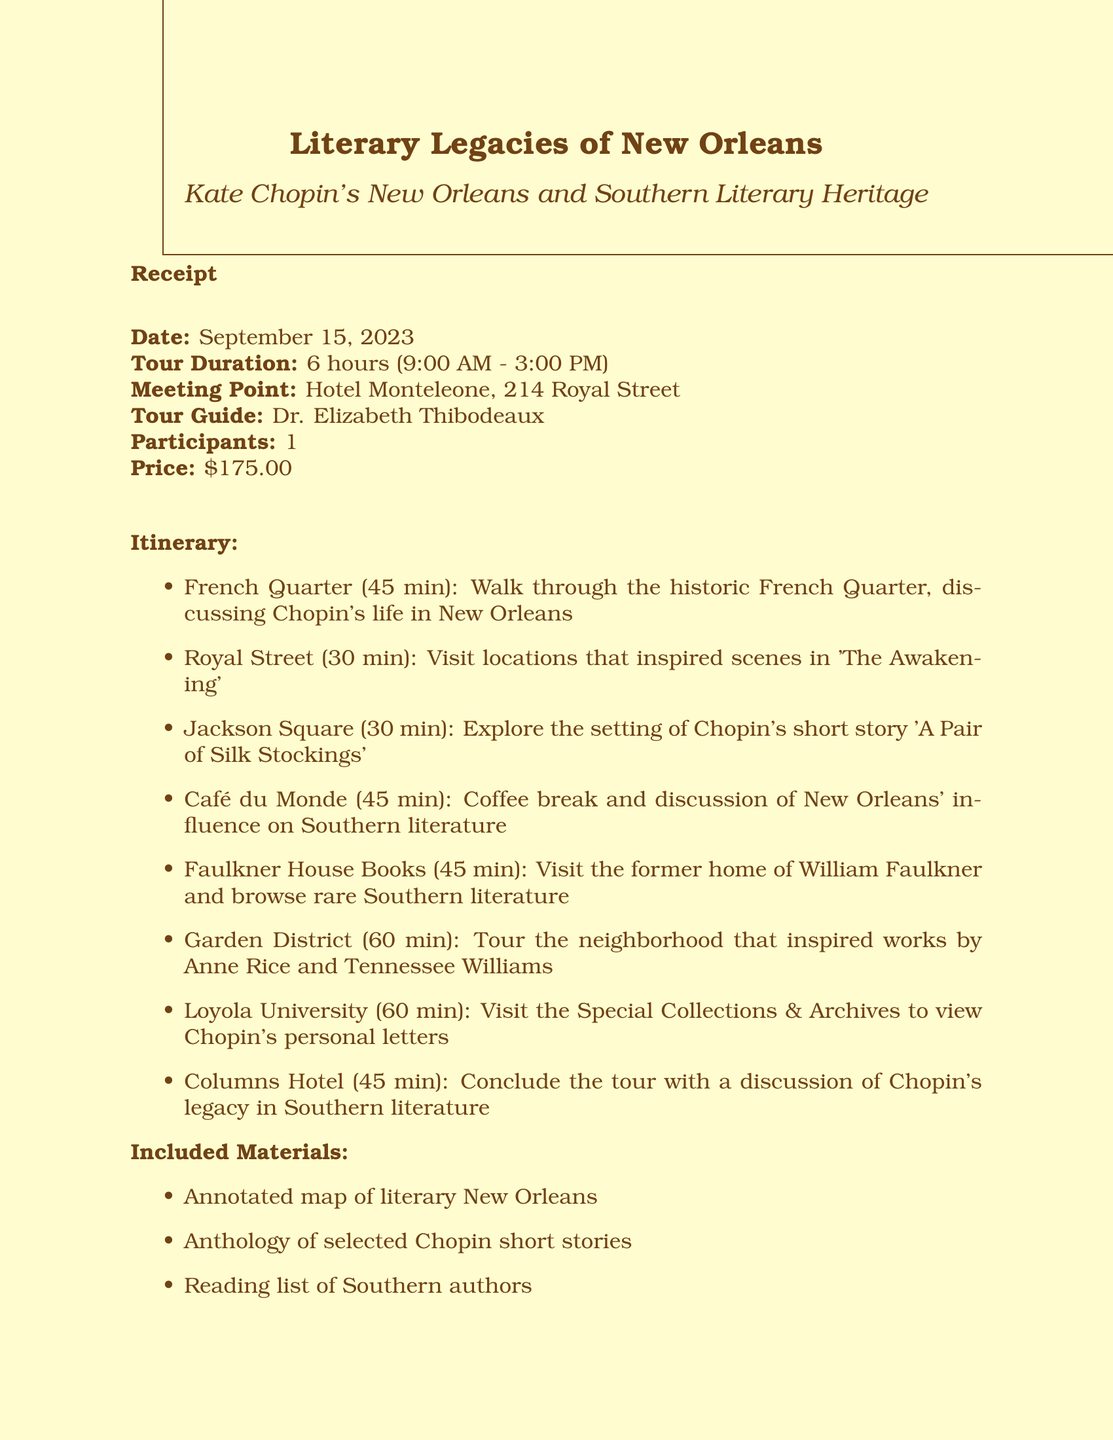What is the name of the tour company? The name of the tour company is found at the beginning of the document.
Answer: Literary Legacies of New Orleans What is the price of the tour? The price is mentioned in the financial section of the receipt.
Answer: $175.00 What time does the tour start? The start time is specified in the tour's schedule details.
Answer: 9:00 AM Which university will be visited during the tour? The university is listed in the itinerary as one of the tour locations.
Answer: Loyola University How long is the duration of the tour? This information is clearly stated under the tour duration heading.
Answer: 6 hours What is included in the materials provided? The included materials are listed separately for easy reference.
Answer: Annotated map of literary New Orleans Who is the tour guide? The name of the tour guide is specified in the guide's section of the document.
Answer: Dr. Elizabeth Thibodeaux What location concludes the tour? The concluding location is mentioned in the tour's itinerary.
Answer: Columns Hotel What is the cancellation policy? The cancellation policy is briefly outlined towards the end of the document.
Answer: Full refund if canceled 48 hours before the tour start time 